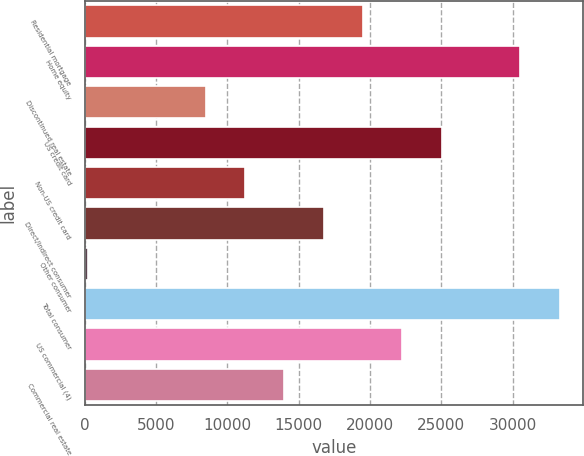<chart> <loc_0><loc_0><loc_500><loc_500><bar_chart><fcel>Residential mortgage<fcel>Home equity<fcel>Discontinued real estate<fcel>US credit card<fcel>Non-US credit card<fcel>Direct/Indirect consumer<fcel>Other consumer<fcel>Total consumer<fcel>US commercial (4)<fcel>Commercial real estate<nl><fcel>19510.7<fcel>30543.1<fcel>8478.3<fcel>25026.9<fcel>11236.4<fcel>16752.6<fcel>204<fcel>33301.2<fcel>22268.8<fcel>13994.5<nl></chart> 